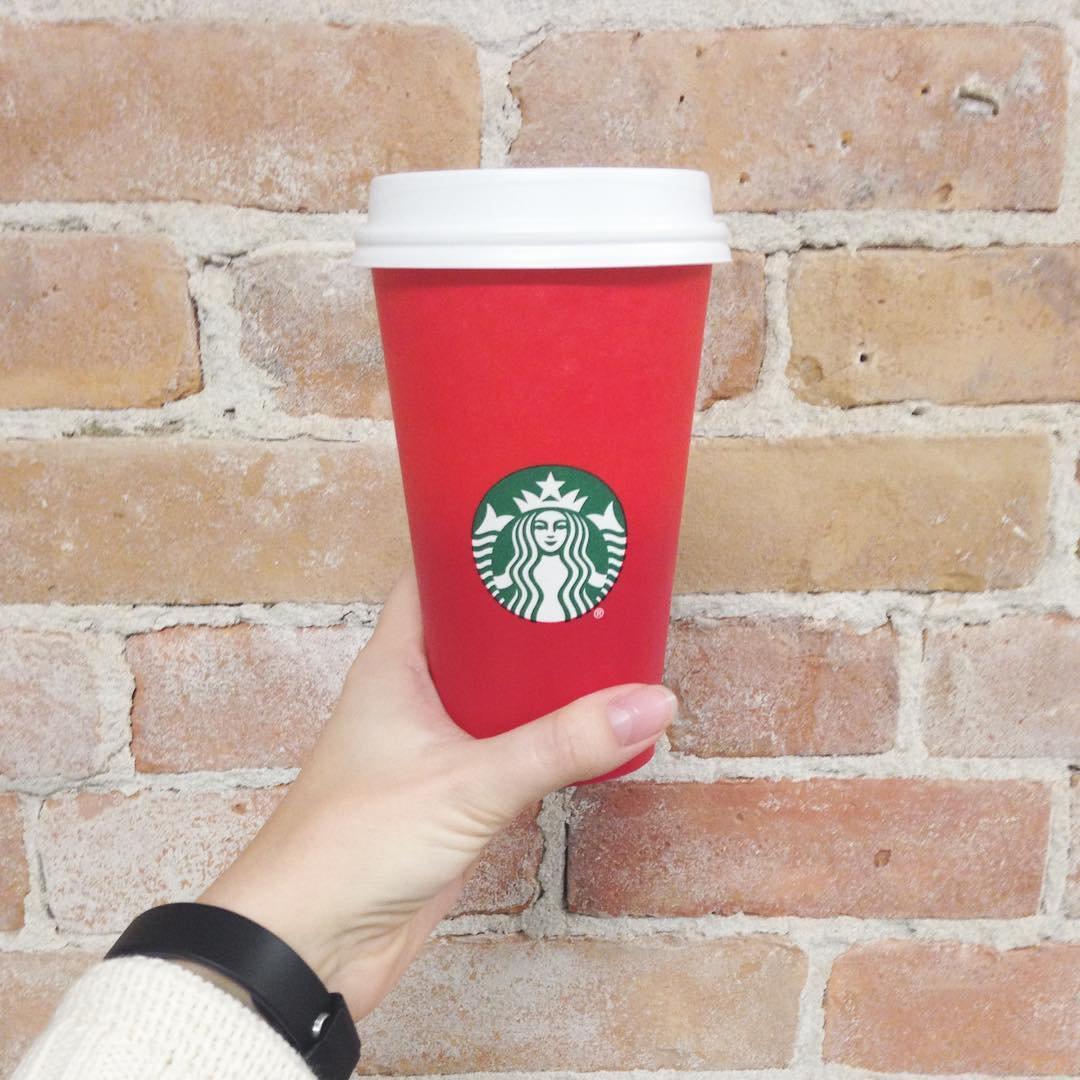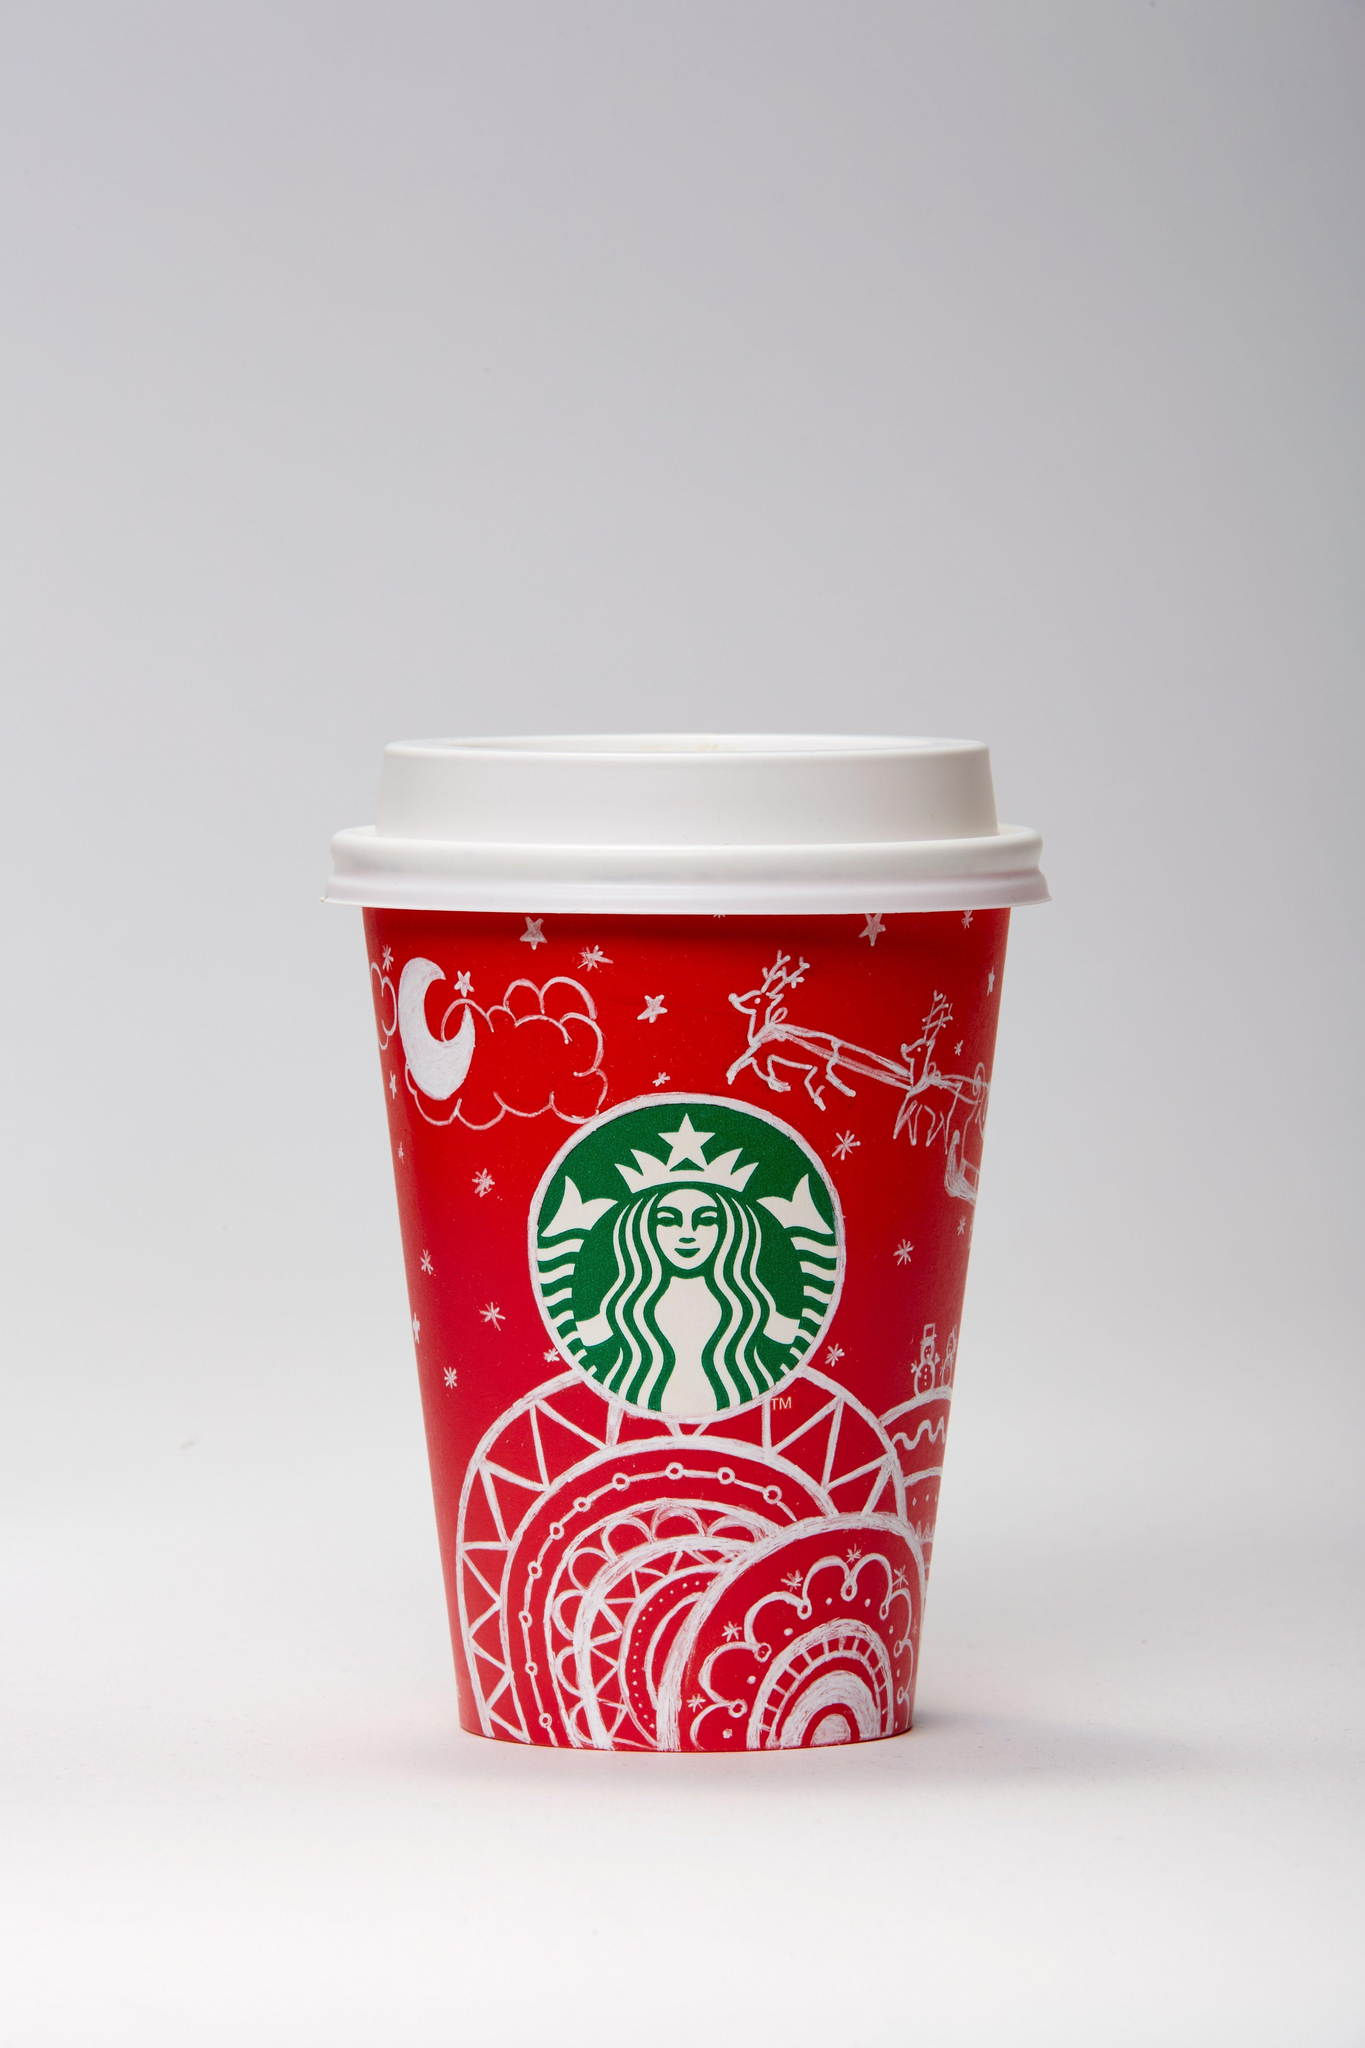The first image is the image on the left, the second image is the image on the right. Analyze the images presented: Is the assertion "There are two cups total." valid? Answer yes or no. Yes. The first image is the image on the left, the second image is the image on the right. Given the left and right images, does the statement "There is a total of two red coffee cups." hold true? Answer yes or no. Yes. 